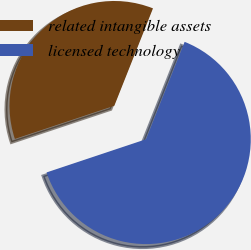Convert chart to OTSL. <chart><loc_0><loc_0><loc_500><loc_500><pie_chart><fcel>related intangible assets<fcel>licensed technology<nl><fcel>36.14%<fcel>63.86%<nl></chart> 